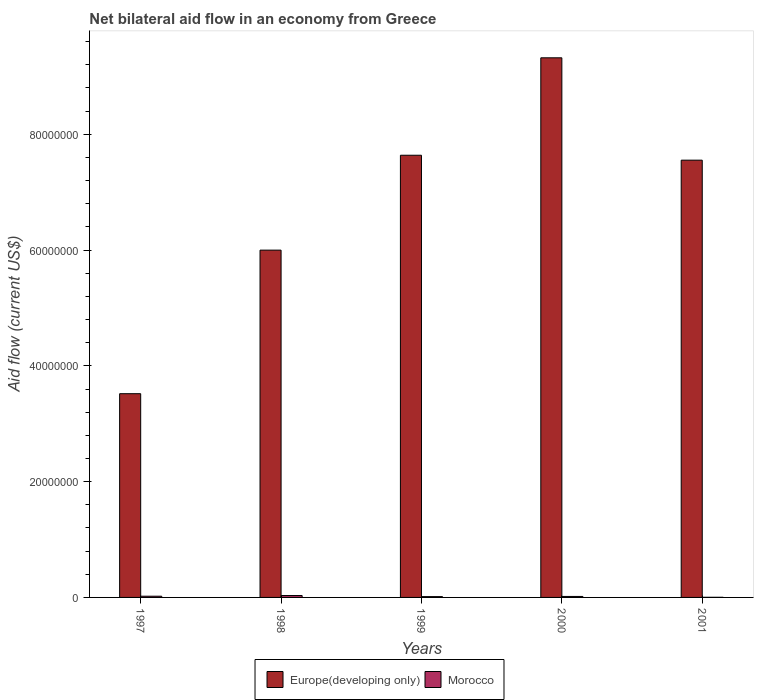How many different coloured bars are there?
Make the answer very short. 2. How many bars are there on the 5th tick from the left?
Give a very brief answer. 2. How many bars are there on the 3rd tick from the right?
Offer a terse response. 2. In how many cases, is the number of bars for a given year not equal to the number of legend labels?
Offer a terse response. 0. What is the net bilateral aid flow in Morocco in 2000?
Provide a short and direct response. 1.70e+05. Across all years, what is the maximum net bilateral aid flow in Europe(developing only)?
Your answer should be very brief. 9.32e+07. Across all years, what is the minimum net bilateral aid flow in Europe(developing only)?
Make the answer very short. 3.52e+07. In which year was the net bilateral aid flow in Europe(developing only) minimum?
Offer a very short reply. 1997. What is the total net bilateral aid flow in Morocco in the graph?
Offer a very short reply. 8.70e+05. What is the difference between the net bilateral aid flow in Europe(developing only) in 1999 and that in 2000?
Make the answer very short. -1.68e+07. What is the difference between the net bilateral aid flow in Europe(developing only) in 1998 and the net bilateral aid flow in Morocco in 1999?
Keep it short and to the point. 5.98e+07. What is the average net bilateral aid flow in Morocco per year?
Your answer should be compact. 1.74e+05. In the year 1999, what is the difference between the net bilateral aid flow in Morocco and net bilateral aid flow in Europe(developing only)?
Keep it short and to the point. -7.62e+07. In how many years, is the net bilateral aid flow in Europe(developing only) greater than 64000000 US$?
Offer a terse response. 3. What is the ratio of the net bilateral aid flow in Morocco in 1998 to that in 2000?
Provide a succinct answer. 1.94. Is the net bilateral aid flow in Europe(developing only) in 1997 less than that in 2000?
Provide a succinct answer. Yes. Is the difference between the net bilateral aid flow in Morocco in 1997 and 1999 greater than the difference between the net bilateral aid flow in Europe(developing only) in 1997 and 1999?
Ensure brevity in your answer.  Yes. What is the difference between the highest and the second highest net bilateral aid flow in Europe(developing only)?
Offer a terse response. 1.68e+07. What is the difference between the highest and the lowest net bilateral aid flow in Europe(developing only)?
Your answer should be very brief. 5.80e+07. In how many years, is the net bilateral aid flow in Europe(developing only) greater than the average net bilateral aid flow in Europe(developing only) taken over all years?
Provide a succinct answer. 3. Is the sum of the net bilateral aid flow in Morocco in 1999 and 2000 greater than the maximum net bilateral aid flow in Europe(developing only) across all years?
Provide a succinct answer. No. What does the 1st bar from the left in 1998 represents?
Your response must be concise. Europe(developing only). What does the 2nd bar from the right in 1998 represents?
Ensure brevity in your answer.  Europe(developing only). How many bars are there?
Provide a succinct answer. 10. Are all the bars in the graph horizontal?
Make the answer very short. No. How many years are there in the graph?
Keep it short and to the point. 5. What is the difference between two consecutive major ticks on the Y-axis?
Your answer should be very brief. 2.00e+07. Are the values on the major ticks of Y-axis written in scientific E-notation?
Keep it short and to the point. No. Does the graph contain grids?
Your answer should be very brief. No. Where does the legend appear in the graph?
Give a very brief answer. Bottom center. How many legend labels are there?
Give a very brief answer. 2. How are the legend labels stacked?
Ensure brevity in your answer.  Horizontal. What is the title of the graph?
Offer a very short reply. Net bilateral aid flow in an economy from Greece. Does "Sub-Saharan Africa (developing only)" appear as one of the legend labels in the graph?
Your response must be concise. No. What is the label or title of the X-axis?
Keep it short and to the point. Years. What is the Aid flow (current US$) of Europe(developing only) in 1997?
Your answer should be compact. 3.52e+07. What is the Aid flow (current US$) of Morocco in 1997?
Provide a short and direct response. 2.10e+05. What is the Aid flow (current US$) of Europe(developing only) in 1998?
Your answer should be compact. 6.00e+07. What is the Aid flow (current US$) in Europe(developing only) in 1999?
Offer a terse response. 7.64e+07. What is the Aid flow (current US$) of Europe(developing only) in 2000?
Your response must be concise. 9.32e+07. What is the Aid flow (current US$) of Morocco in 2000?
Your response must be concise. 1.70e+05. What is the Aid flow (current US$) in Europe(developing only) in 2001?
Provide a short and direct response. 7.55e+07. What is the Aid flow (current US$) of Morocco in 2001?
Offer a terse response. 2.00e+04. Across all years, what is the maximum Aid flow (current US$) in Europe(developing only)?
Offer a very short reply. 9.32e+07. Across all years, what is the maximum Aid flow (current US$) in Morocco?
Provide a short and direct response. 3.30e+05. Across all years, what is the minimum Aid flow (current US$) of Europe(developing only)?
Keep it short and to the point. 3.52e+07. Across all years, what is the minimum Aid flow (current US$) of Morocco?
Offer a very short reply. 2.00e+04. What is the total Aid flow (current US$) in Europe(developing only) in the graph?
Your response must be concise. 3.40e+08. What is the total Aid flow (current US$) in Morocco in the graph?
Provide a succinct answer. 8.70e+05. What is the difference between the Aid flow (current US$) of Europe(developing only) in 1997 and that in 1998?
Your answer should be compact. -2.48e+07. What is the difference between the Aid flow (current US$) of Morocco in 1997 and that in 1998?
Offer a very short reply. -1.20e+05. What is the difference between the Aid flow (current US$) in Europe(developing only) in 1997 and that in 1999?
Make the answer very short. -4.12e+07. What is the difference between the Aid flow (current US$) in Europe(developing only) in 1997 and that in 2000?
Offer a very short reply. -5.80e+07. What is the difference between the Aid flow (current US$) in Morocco in 1997 and that in 2000?
Your answer should be very brief. 4.00e+04. What is the difference between the Aid flow (current US$) of Europe(developing only) in 1997 and that in 2001?
Offer a terse response. -4.03e+07. What is the difference between the Aid flow (current US$) of Europe(developing only) in 1998 and that in 1999?
Your response must be concise. -1.64e+07. What is the difference between the Aid flow (current US$) in Morocco in 1998 and that in 1999?
Provide a short and direct response. 1.90e+05. What is the difference between the Aid flow (current US$) in Europe(developing only) in 1998 and that in 2000?
Ensure brevity in your answer.  -3.32e+07. What is the difference between the Aid flow (current US$) of Morocco in 1998 and that in 2000?
Make the answer very short. 1.60e+05. What is the difference between the Aid flow (current US$) of Europe(developing only) in 1998 and that in 2001?
Make the answer very short. -1.55e+07. What is the difference between the Aid flow (current US$) of Morocco in 1998 and that in 2001?
Give a very brief answer. 3.10e+05. What is the difference between the Aid flow (current US$) of Europe(developing only) in 1999 and that in 2000?
Offer a very short reply. -1.68e+07. What is the difference between the Aid flow (current US$) of Morocco in 1999 and that in 2000?
Offer a very short reply. -3.00e+04. What is the difference between the Aid flow (current US$) in Europe(developing only) in 1999 and that in 2001?
Keep it short and to the point. 8.50e+05. What is the difference between the Aid flow (current US$) in Morocco in 1999 and that in 2001?
Offer a very short reply. 1.20e+05. What is the difference between the Aid flow (current US$) of Europe(developing only) in 2000 and that in 2001?
Your answer should be very brief. 1.77e+07. What is the difference between the Aid flow (current US$) in Morocco in 2000 and that in 2001?
Your answer should be very brief. 1.50e+05. What is the difference between the Aid flow (current US$) of Europe(developing only) in 1997 and the Aid flow (current US$) of Morocco in 1998?
Your response must be concise. 3.49e+07. What is the difference between the Aid flow (current US$) in Europe(developing only) in 1997 and the Aid flow (current US$) in Morocco in 1999?
Provide a succinct answer. 3.50e+07. What is the difference between the Aid flow (current US$) in Europe(developing only) in 1997 and the Aid flow (current US$) in Morocco in 2000?
Your response must be concise. 3.50e+07. What is the difference between the Aid flow (current US$) of Europe(developing only) in 1997 and the Aid flow (current US$) of Morocco in 2001?
Your response must be concise. 3.52e+07. What is the difference between the Aid flow (current US$) in Europe(developing only) in 1998 and the Aid flow (current US$) in Morocco in 1999?
Offer a very short reply. 5.98e+07. What is the difference between the Aid flow (current US$) in Europe(developing only) in 1998 and the Aid flow (current US$) in Morocco in 2000?
Your answer should be compact. 5.98e+07. What is the difference between the Aid flow (current US$) of Europe(developing only) in 1998 and the Aid flow (current US$) of Morocco in 2001?
Make the answer very short. 6.00e+07. What is the difference between the Aid flow (current US$) of Europe(developing only) in 1999 and the Aid flow (current US$) of Morocco in 2000?
Provide a succinct answer. 7.62e+07. What is the difference between the Aid flow (current US$) of Europe(developing only) in 1999 and the Aid flow (current US$) of Morocco in 2001?
Provide a short and direct response. 7.64e+07. What is the difference between the Aid flow (current US$) in Europe(developing only) in 2000 and the Aid flow (current US$) in Morocco in 2001?
Offer a very short reply. 9.32e+07. What is the average Aid flow (current US$) of Europe(developing only) per year?
Your response must be concise. 6.81e+07. What is the average Aid flow (current US$) of Morocco per year?
Give a very brief answer. 1.74e+05. In the year 1997, what is the difference between the Aid flow (current US$) in Europe(developing only) and Aid flow (current US$) in Morocco?
Ensure brevity in your answer.  3.50e+07. In the year 1998, what is the difference between the Aid flow (current US$) of Europe(developing only) and Aid flow (current US$) of Morocco?
Offer a very short reply. 5.97e+07. In the year 1999, what is the difference between the Aid flow (current US$) in Europe(developing only) and Aid flow (current US$) in Morocco?
Provide a short and direct response. 7.62e+07. In the year 2000, what is the difference between the Aid flow (current US$) in Europe(developing only) and Aid flow (current US$) in Morocco?
Your response must be concise. 9.30e+07. In the year 2001, what is the difference between the Aid flow (current US$) in Europe(developing only) and Aid flow (current US$) in Morocco?
Provide a short and direct response. 7.55e+07. What is the ratio of the Aid flow (current US$) of Europe(developing only) in 1997 to that in 1998?
Your answer should be very brief. 0.59. What is the ratio of the Aid flow (current US$) in Morocco in 1997 to that in 1998?
Provide a succinct answer. 0.64. What is the ratio of the Aid flow (current US$) in Europe(developing only) in 1997 to that in 1999?
Make the answer very short. 0.46. What is the ratio of the Aid flow (current US$) in Morocco in 1997 to that in 1999?
Make the answer very short. 1.5. What is the ratio of the Aid flow (current US$) of Europe(developing only) in 1997 to that in 2000?
Provide a short and direct response. 0.38. What is the ratio of the Aid flow (current US$) in Morocco in 1997 to that in 2000?
Provide a succinct answer. 1.24. What is the ratio of the Aid flow (current US$) in Europe(developing only) in 1997 to that in 2001?
Offer a terse response. 0.47. What is the ratio of the Aid flow (current US$) of Morocco in 1997 to that in 2001?
Provide a succinct answer. 10.5. What is the ratio of the Aid flow (current US$) of Europe(developing only) in 1998 to that in 1999?
Ensure brevity in your answer.  0.79. What is the ratio of the Aid flow (current US$) of Morocco in 1998 to that in 1999?
Give a very brief answer. 2.36. What is the ratio of the Aid flow (current US$) of Europe(developing only) in 1998 to that in 2000?
Your answer should be very brief. 0.64. What is the ratio of the Aid flow (current US$) of Morocco in 1998 to that in 2000?
Offer a very short reply. 1.94. What is the ratio of the Aid flow (current US$) in Europe(developing only) in 1998 to that in 2001?
Your answer should be compact. 0.79. What is the ratio of the Aid flow (current US$) of Morocco in 1998 to that in 2001?
Offer a terse response. 16.5. What is the ratio of the Aid flow (current US$) of Europe(developing only) in 1999 to that in 2000?
Your response must be concise. 0.82. What is the ratio of the Aid flow (current US$) in Morocco in 1999 to that in 2000?
Make the answer very short. 0.82. What is the ratio of the Aid flow (current US$) in Europe(developing only) in 1999 to that in 2001?
Make the answer very short. 1.01. What is the ratio of the Aid flow (current US$) in Europe(developing only) in 2000 to that in 2001?
Make the answer very short. 1.23. What is the ratio of the Aid flow (current US$) in Morocco in 2000 to that in 2001?
Your answer should be very brief. 8.5. What is the difference between the highest and the second highest Aid flow (current US$) of Europe(developing only)?
Make the answer very short. 1.68e+07. What is the difference between the highest and the lowest Aid flow (current US$) of Europe(developing only)?
Ensure brevity in your answer.  5.80e+07. 